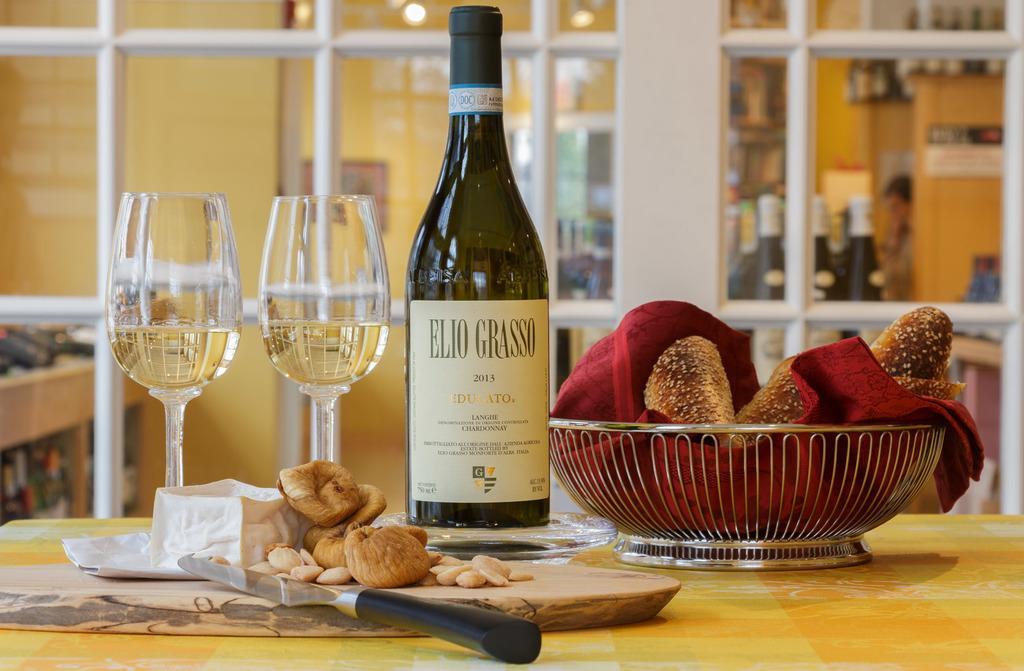Can you describe this image briefly? In this image there is table visible. On the table left side, there are the two glasses,first glass contain a drink and second glass also contain a drink. On the right side of right side there is a bowl on the table contain a cloth and food on that cloth. And the middle there is a bottle kept on the table. On the bottle there is some text written on that. On the center of the image there is a wooden plate kept on the table. And there is a knife on the wooden plate. There are some ground nuts on the wooden plate, there is a paper on the wooden plate. back side of the image there is a window. Back side of the window wall is visible. On the wall lights are visible. On the wall there is a photo frame attached to the wall. Back side of the window there is a man standing. There are few bottle kept back side of the window. 